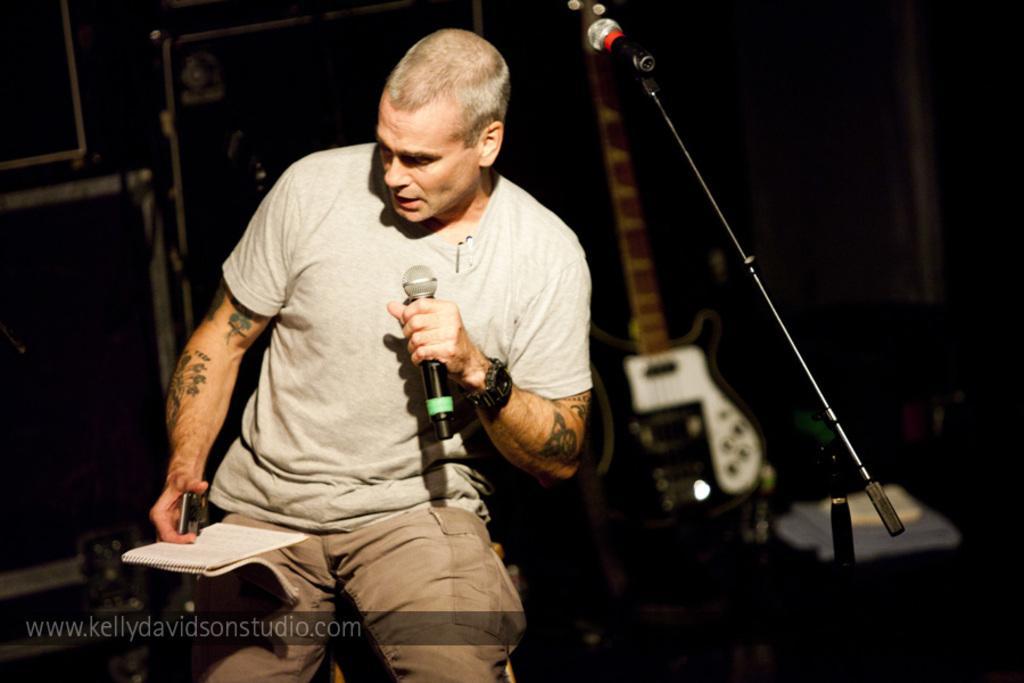How would you summarize this image in a sentence or two? In this image I can see a man wearing t-shirt, holding a mike in his left hand and one book in his right hand. On the right side of the image I can see a mike stand. In the background there is a guitar. 